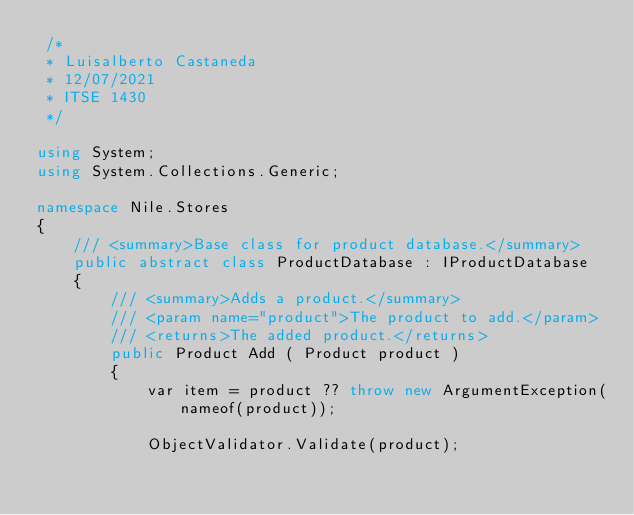Convert code to text. <code><loc_0><loc_0><loc_500><loc_500><_C#_> /*
 * Luisalberto Castaneda
 * 12/07/2021
 * ITSE 1430
 */

using System;
using System.Collections.Generic;

namespace Nile.Stores
{
    /// <summary>Base class for product database.</summary>
    public abstract class ProductDatabase : IProductDatabase
    {        
        /// <summary>Adds a product.</summary>
        /// <param name="product">The product to add.</param>
        /// <returns>The added product.</returns>
        public Product Add ( Product product )
        {
            var item = product ?? throw new ArgumentException(nameof(product));

            ObjectValidator.Validate(product);
</code> 